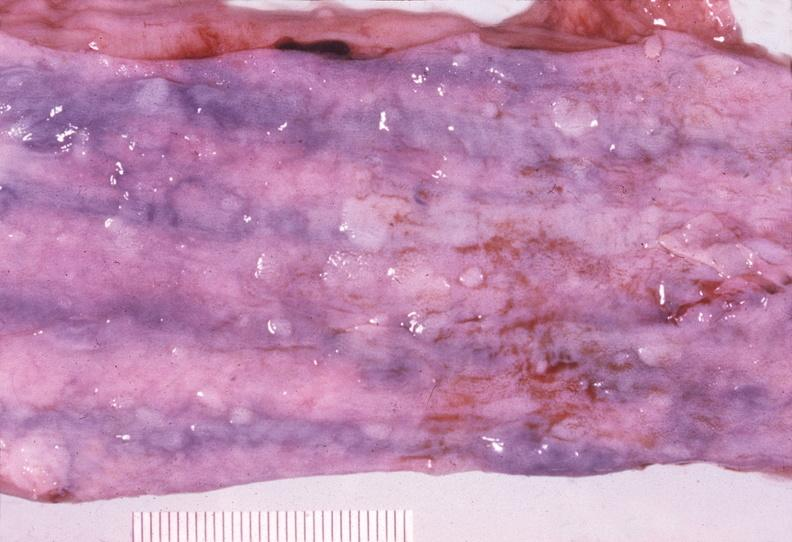what is present?
Answer the question using a single word or phrase. Gastrointestinal 